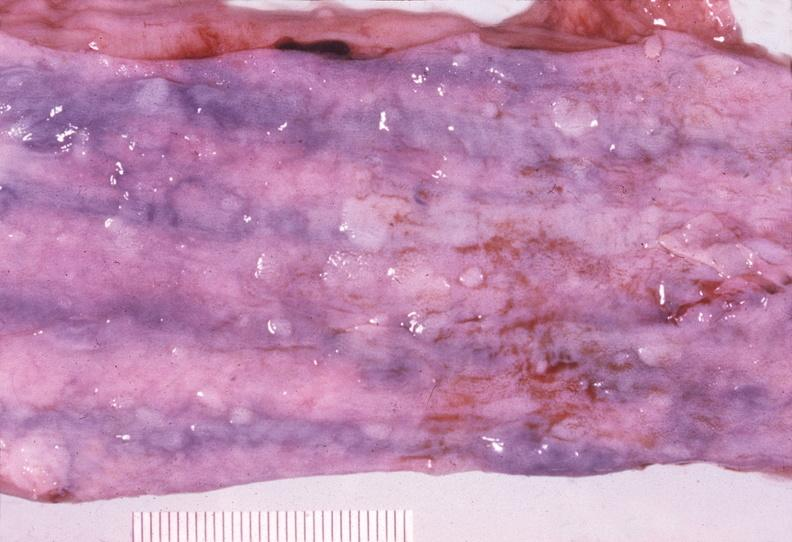what is present?
Answer the question using a single word or phrase. Gastrointestinal 